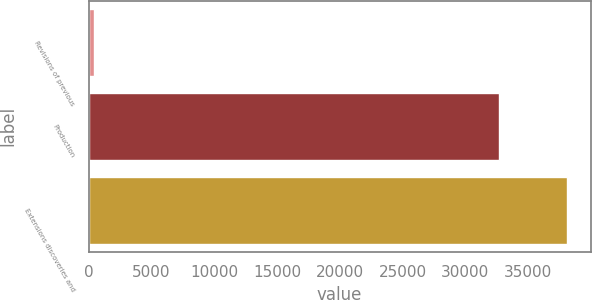Convert chart. <chart><loc_0><loc_0><loc_500><loc_500><bar_chart><fcel>Revisions of previous<fcel>Production<fcel>Extensions discoveries and<nl><fcel>457<fcel>32690<fcel>38074<nl></chart> 